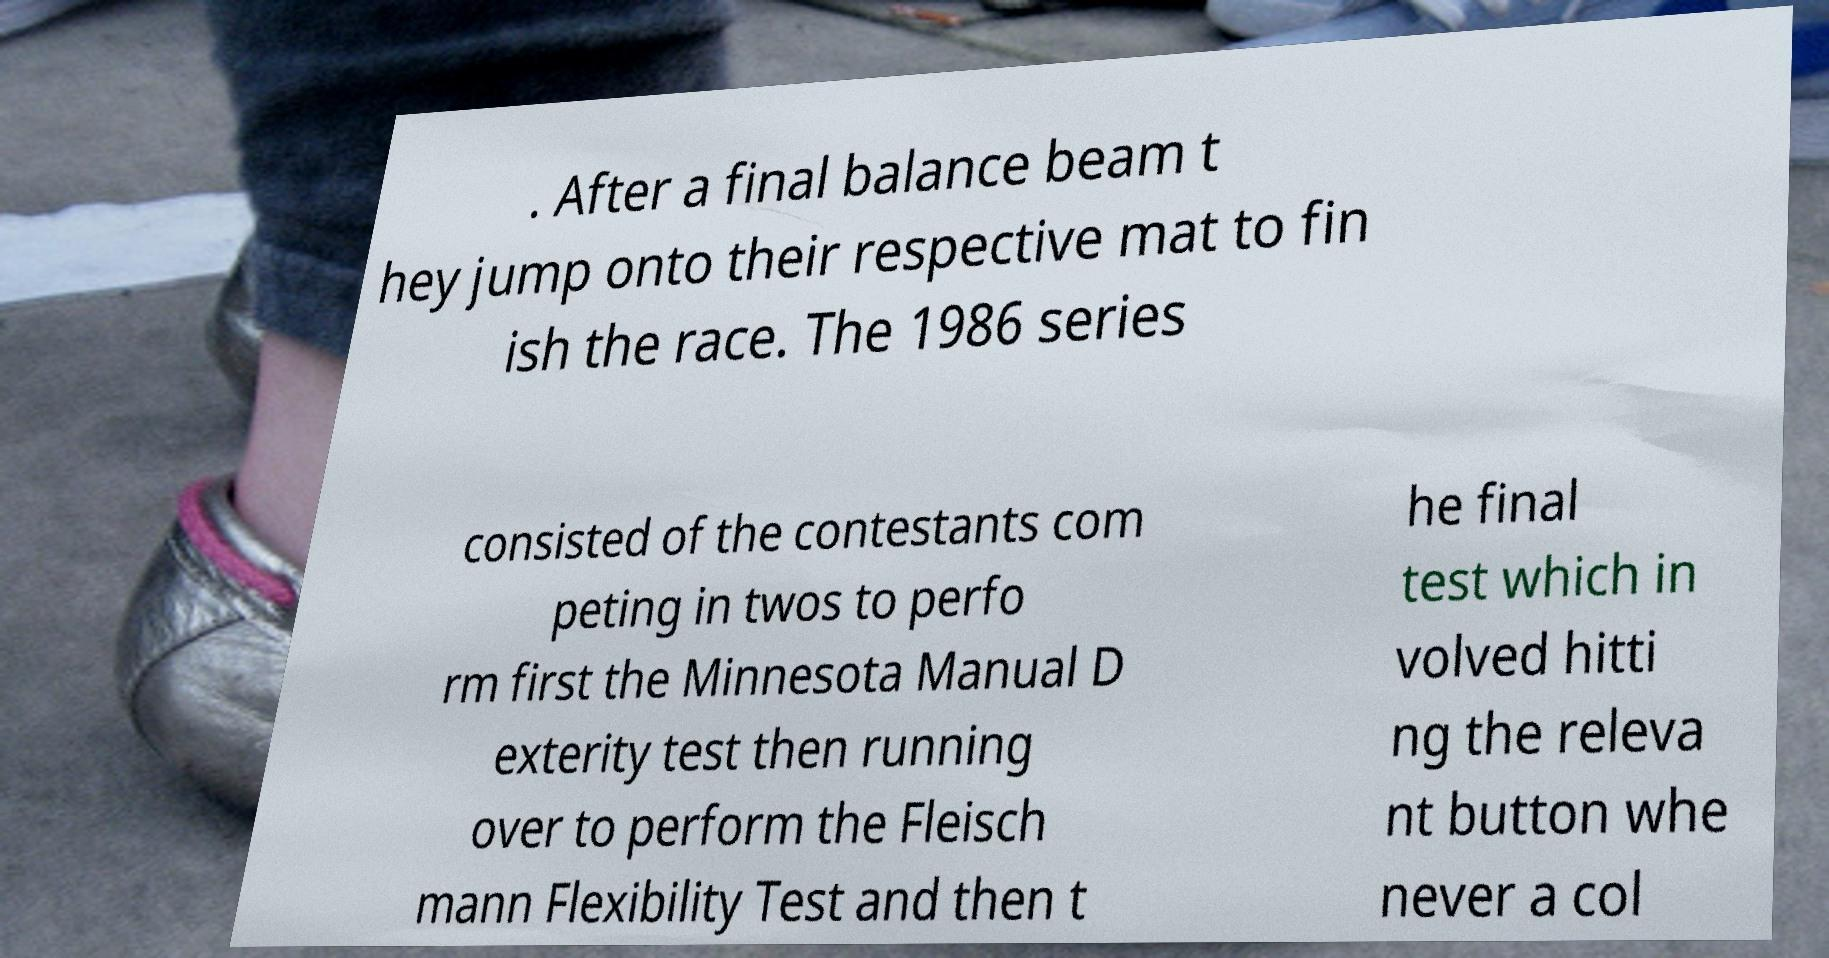Please identify and transcribe the text found in this image. . After a final balance beam t hey jump onto their respective mat to fin ish the race. The 1986 series consisted of the contestants com peting in twos to perfo rm first the Minnesota Manual D exterity test then running over to perform the Fleisch mann Flexibility Test and then t he final test which in volved hitti ng the releva nt button whe never a col 